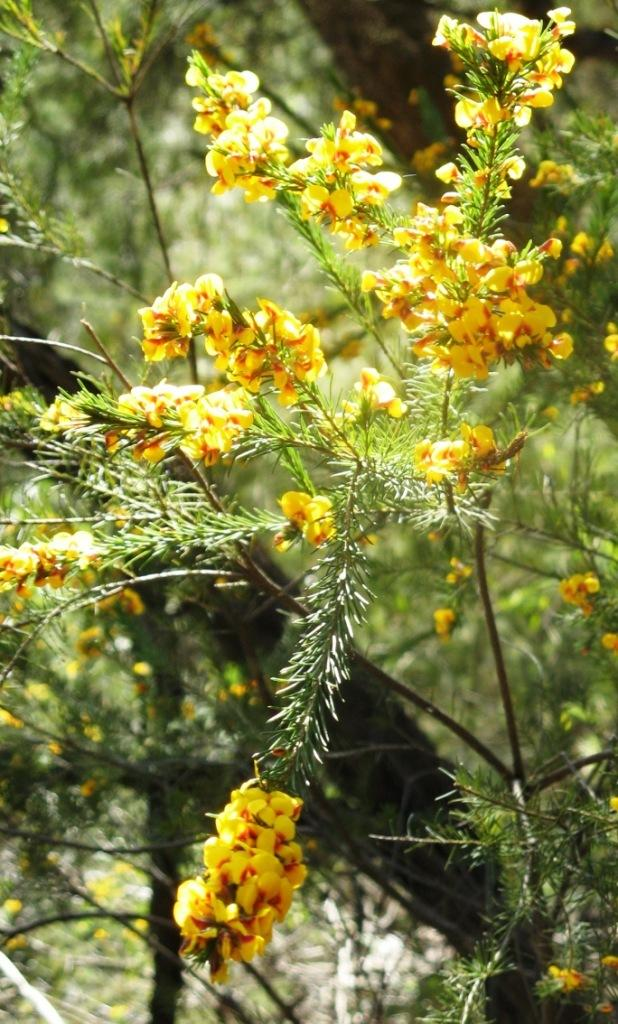What type of living organisms are present in the image? There are plants in the image. What color are the flowers on the plants? The flowers on the plants are yellow. Can you describe the background of the image? The background of the image is blurred. What nation is represented by the flag in the image? There is no flag present in the image, so it is not possible to determine which nation might be represented. 